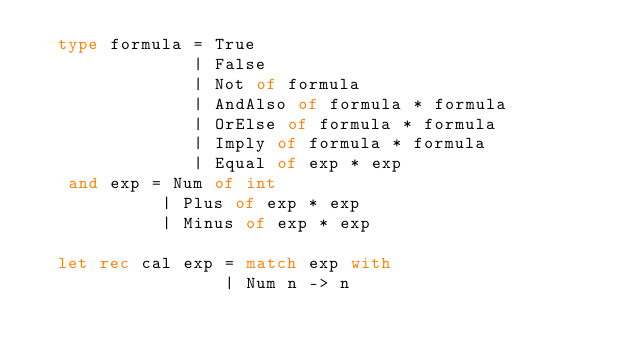Convert code to text. <code><loc_0><loc_0><loc_500><loc_500><_OCaml_>  type formula = True
               | False
               | Not of formula
               | AndAlso of formula * formula
               | OrElse of formula * formula
               | Imply of formula * formula
               | Equal of exp * exp
   and exp = Num of int
            | Plus of exp * exp
            | Minus of exp * exp

  let rec cal exp = match exp with
                  | Num n -> n</code> 